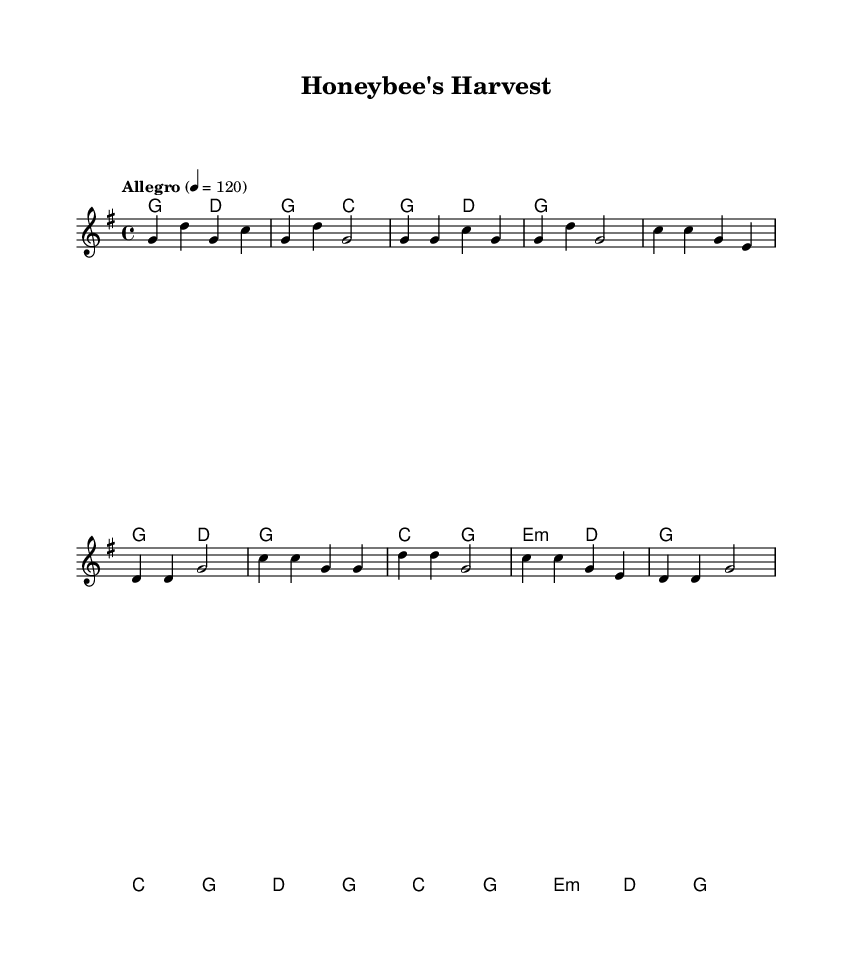What is the key signature of this music? The key signature is G major, which has one sharp (F#). This is determined by the 'g' key indicated at the start of the score.
Answer: G major What is the time signature of this music? The time signature is 4/4, indicated just after the key signature. This means there are four beats in a measure and a quarter note gets one beat.
Answer: 4/4 What is the tempo indication of this piece? The tempo indication is "Allegro" at a speed of 120 beats per minute, which suggests a fast and lively pace for the music. This is specified in the tempo directive at the beginning of the score.
Answer: Allegro, 120 How many measures are in the chorus section? The chorus section consists of four measures, as indicated by the four lines of notation under the chorus label. Each line corresponds to one measure of music.
Answer: 4 What type of chord is introduced in the first measure? The first measure shows a G major chord, as represented by the 'g' in the chord symbols above the staff. This indicates the harmonic foundation for the melody in that measure.
Answer: G major Which section of the music does not have a 'd' chord? In the verse section, specifically the first verse, there are measures with different chords that do not include 'd', making it clear that the 'd' chord appears only later in the sequence.
Answer: Verse What themes do the lyrics of this folk tune likely explore? The themes are centered around rural life and changing seasons, which is typical of folk music and can be inferred from the title "Honeybee's Harvest" and the use of natural imagery.
Answer: Rural life, seasons 